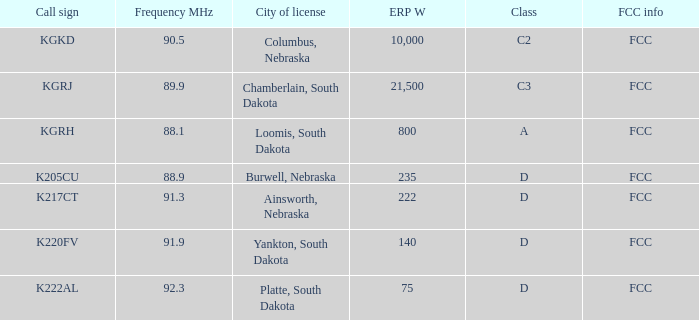What is the overall erp w amount for the call sign k222al? 75.0. 